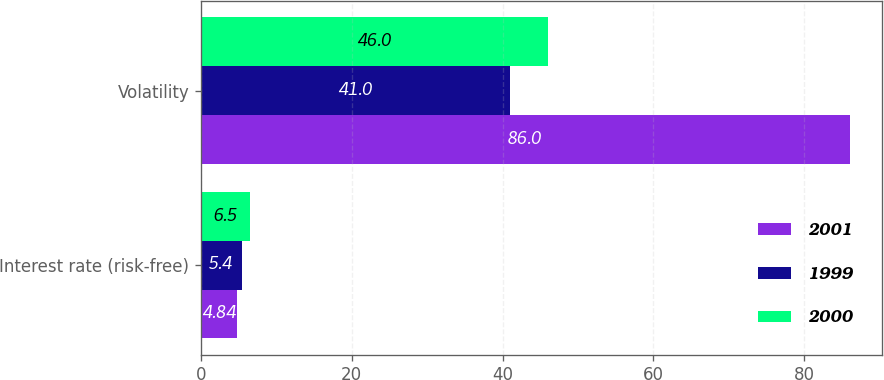Convert chart to OTSL. <chart><loc_0><loc_0><loc_500><loc_500><stacked_bar_chart><ecel><fcel>Interest rate (risk-free)<fcel>Volatility<nl><fcel>2001<fcel>4.84<fcel>86<nl><fcel>1999<fcel>5.4<fcel>41<nl><fcel>2000<fcel>6.5<fcel>46<nl></chart> 